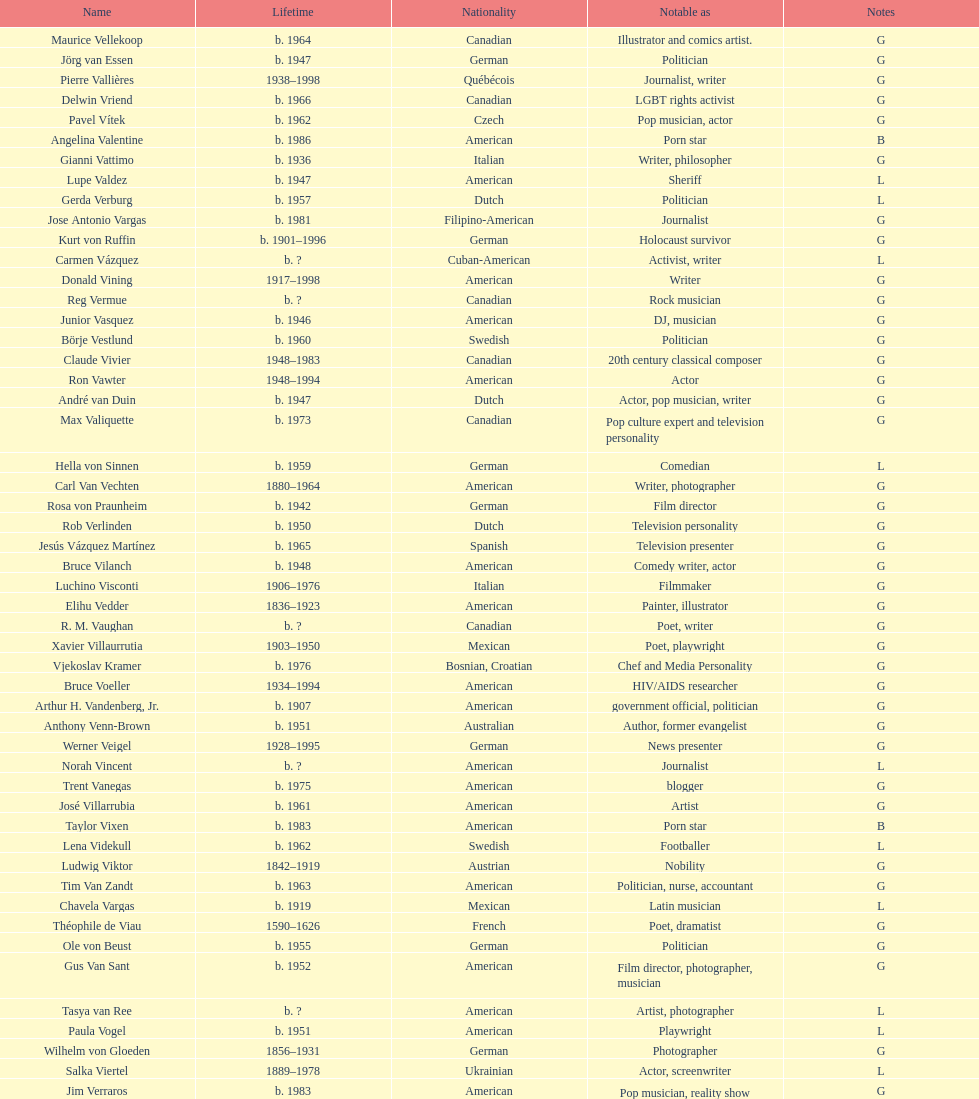Which nationality had the larger amount of names listed? American. 